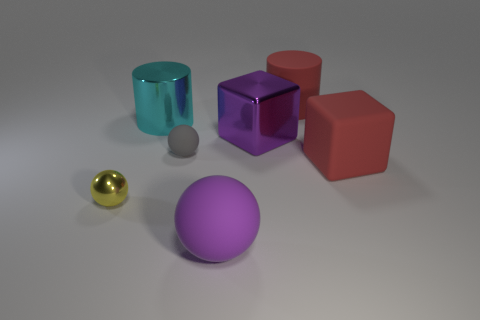Add 3 big red spheres. How many objects exist? 10 Subtract all cylinders. How many objects are left? 5 Add 1 yellow metallic balls. How many yellow metallic balls are left? 2 Add 7 rubber cylinders. How many rubber cylinders exist? 8 Subtract 1 red cylinders. How many objects are left? 6 Subtract all big purple metallic cubes. Subtract all large blocks. How many objects are left? 4 